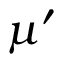<formula> <loc_0><loc_0><loc_500><loc_500>\mu ^ { \prime }</formula> 